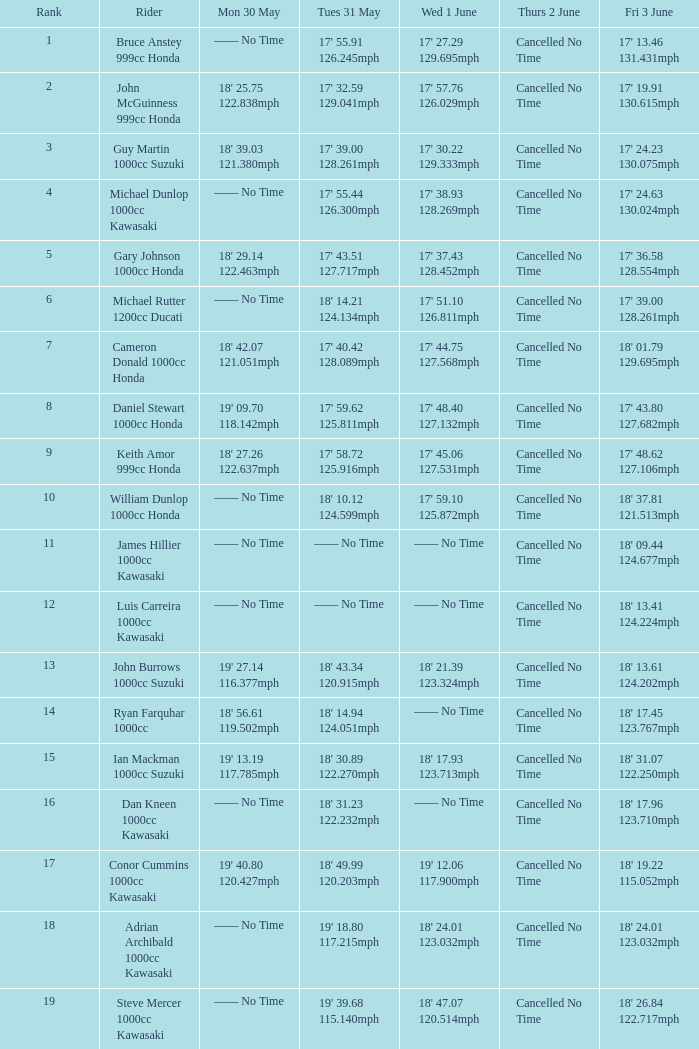What is the mon 30 may duration for the rider whose fri 3 june duration was 17' 1 —— No Time. 